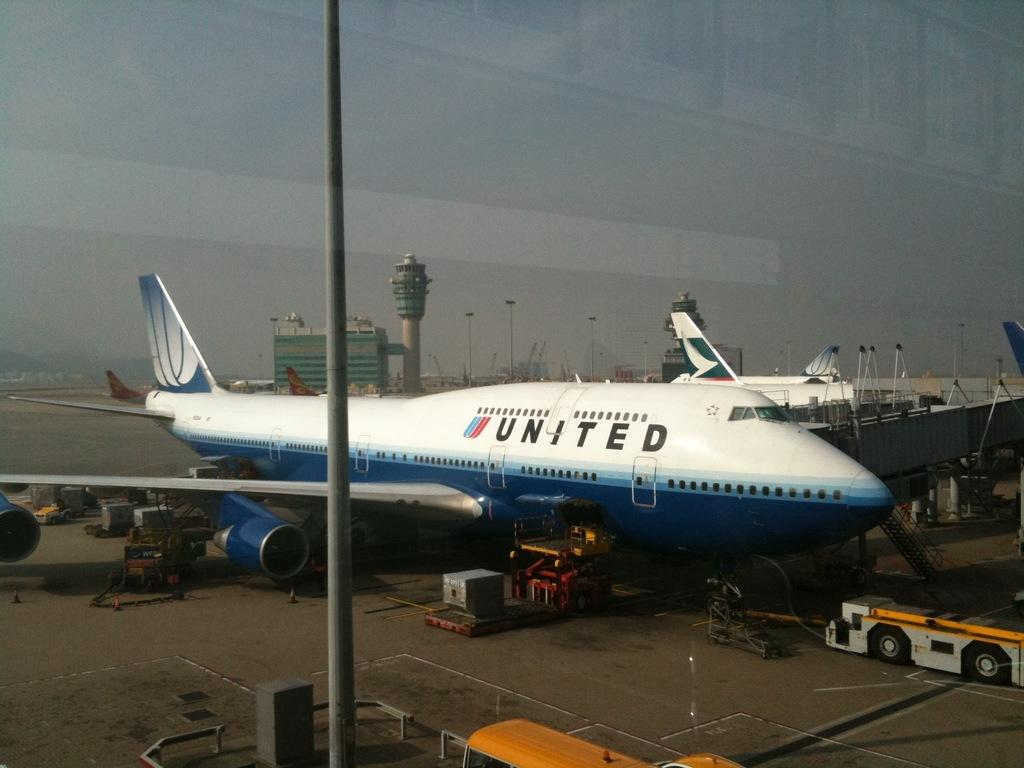<image>
Describe the image concisely. A United aeroplane waiting on tarmac on a sunny day 